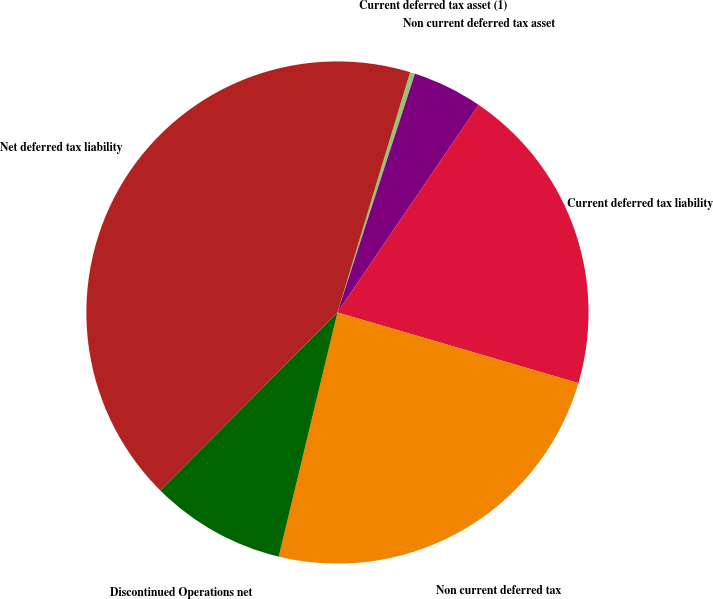<chart> <loc_0><loc_0><loc_500><loc_500><pie_chart><fcel>Current deferred tax asset (1)<fcel>Non current deferred tax asset<fcel>Current deferred tax liability<fcel>Non current deferred tax<fcel>Discontinued Operations net<fcel>Net deferred tax liability<nl><fcel>0.32%<fcel>4.51%<fcel>20.03%<fcel>24.22%<fcel>8.7%<fcel>42.21%<nl></chart> 